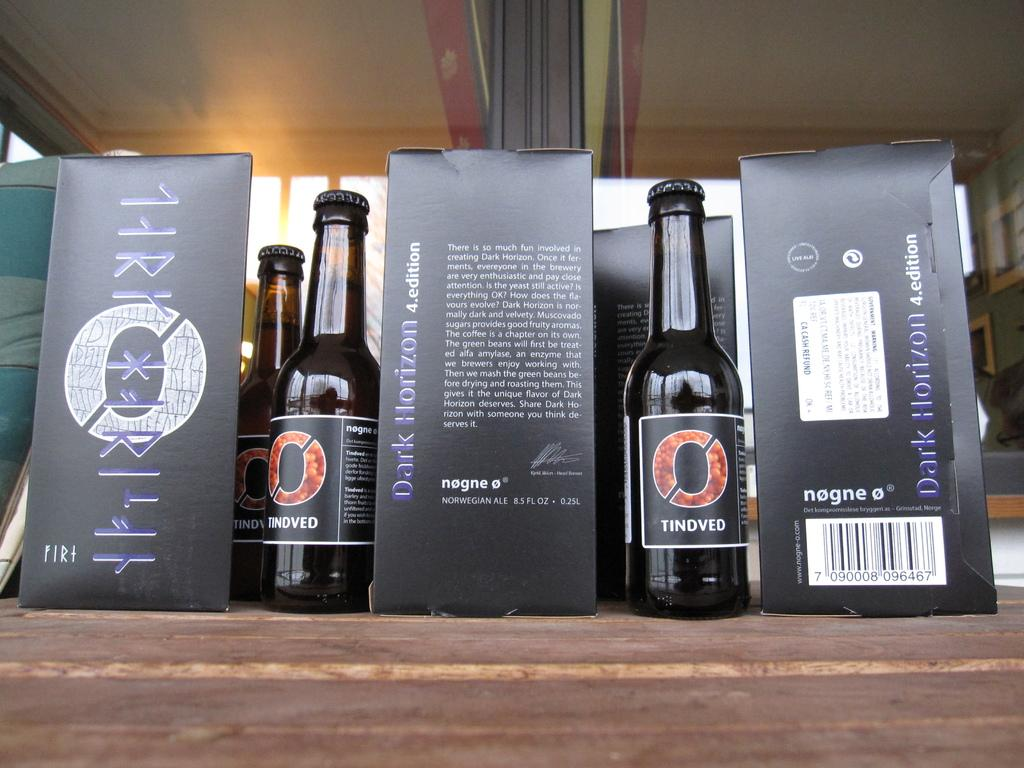<image>
Share a concise interpretation of the image provided. Bottles of Tindved placed next to black boxes. 